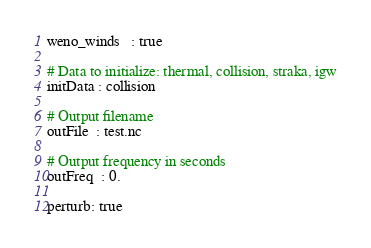Convert code to text. <code><loc_0><loc_0><loc_500><loc_500><_YAML_>
weno_winds   : true

# Data to initialize: thermal, collision, straka, igw
initData : collision

# Output filename
outFile  : test.nc

# Output frequency in seconds
outFreq  : 0.

perturb: true

</code> 